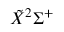<formula> <loc_0><loc_0><loc_500><loc_500>\tilde { X } ^ { 2 } \Sigma ^ { + }</formula> 